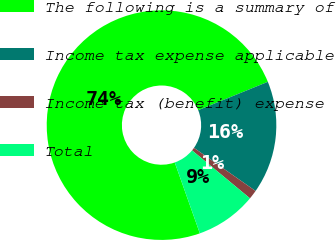Convert chart to OTSL. <chart><loc_0><loc_0><loc_500><loc_500><pie_chart><fcel>The following is a summary of<fcel>Income tax expense applicable<fcel>Income tax (benefit) expense<fcel>Total<nl><fcel>74.27%<fcel>15.88%<fcel>1.28%<fcel>8.58%<nl></chart> 